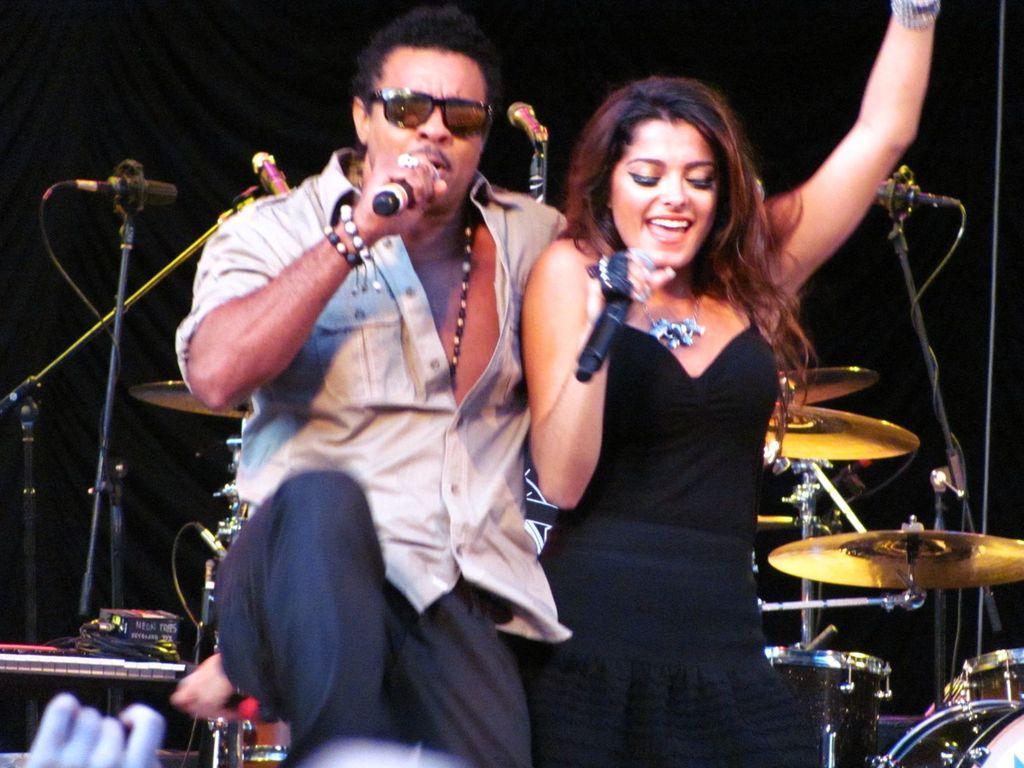Can you describe this image briefly? In this image in front there are two persons holding the mikes. Behind them there are musical instruments. 